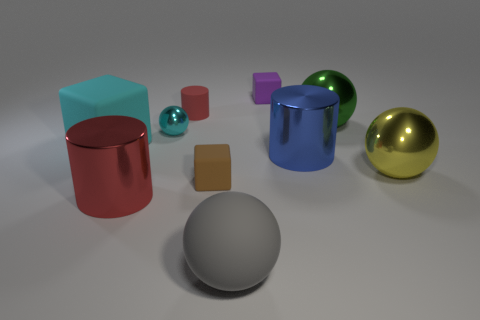Is the number of tiny brown objects to the right of the tiny purple object the same as the number of small matte things behind the blue shiny thing?
Provide a succinct answer. No. What number of other objects are the same color as the small metal thing?
Ensure brevity in your answer.  1. There is a large rubber block; is it the same color as the big matte object in front of the big cyan object?
Offer a terse response. No. What number of brown things are small shiny things or large rubber spheres?
Your response must be concise. 0. Are there the same number of purple rubber blocks that are on the right side of the yellow metal ball and large green things?
Your response must be concise. No. Is there any other thing that has the same size as the cyan ball?
Offer a very short reply. Yes. There is a large matte object that is the same shape as the tiny cyan metallic object; what is its color?
Your answer should be compact. Gray. How many tiny red things have the same shape as the cyan metallic object?
Provide a short and direct response. 0. There is a block that is the same color as the small ball; what is it made of?
Provide a short and direct response. Rubber. How many large cylinders are there?
Offer a very short reply. 2. 